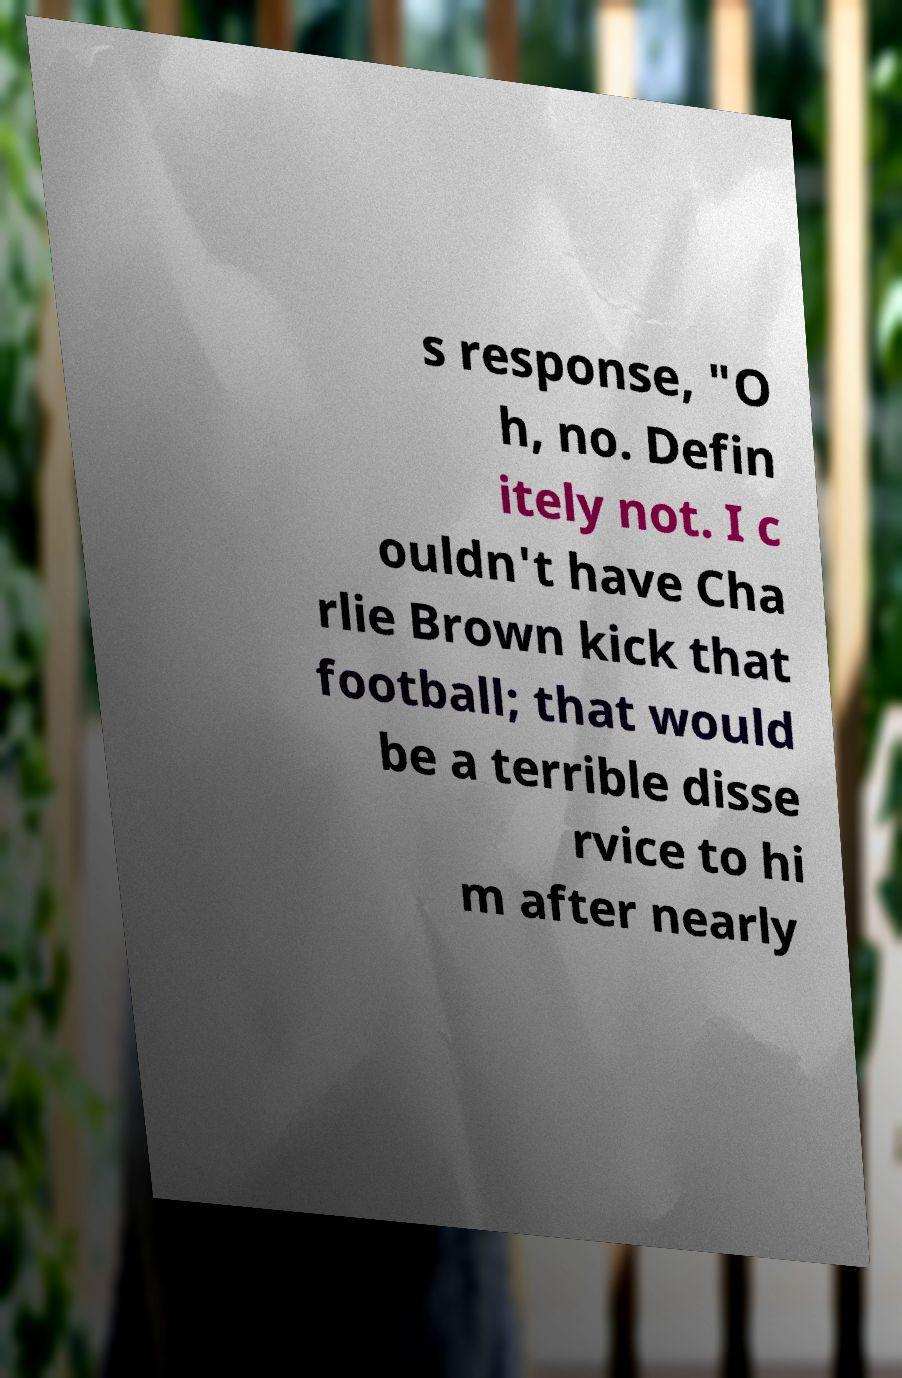Could you extract and type out the text from this image? s response, "O h, no. Defin itely not. I c ouldn't have Cha rlie Brown kick that football; that would be a terrible disse rvice to hi m after nearly 